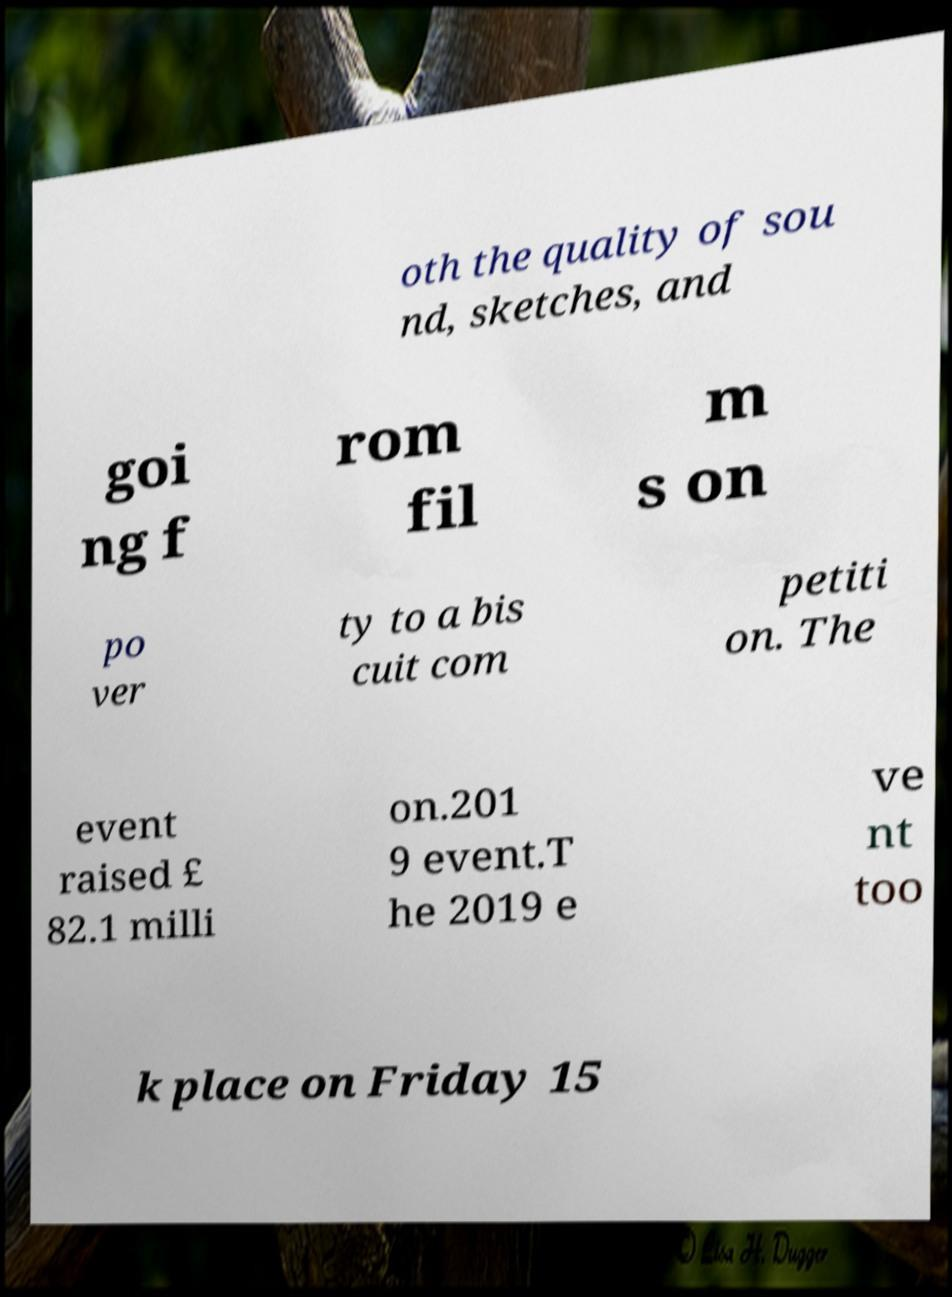Could you assist in decoding the text presented in this image and type it out clearly? oth the quality of sou nd, sketches, and goi ng f rom fil m s on po ver ty to a bis cuit com petiti on. The event raised £ 82.1 milli on.201 9 event.T he 2019 e ve nt too k place on Friday 15 